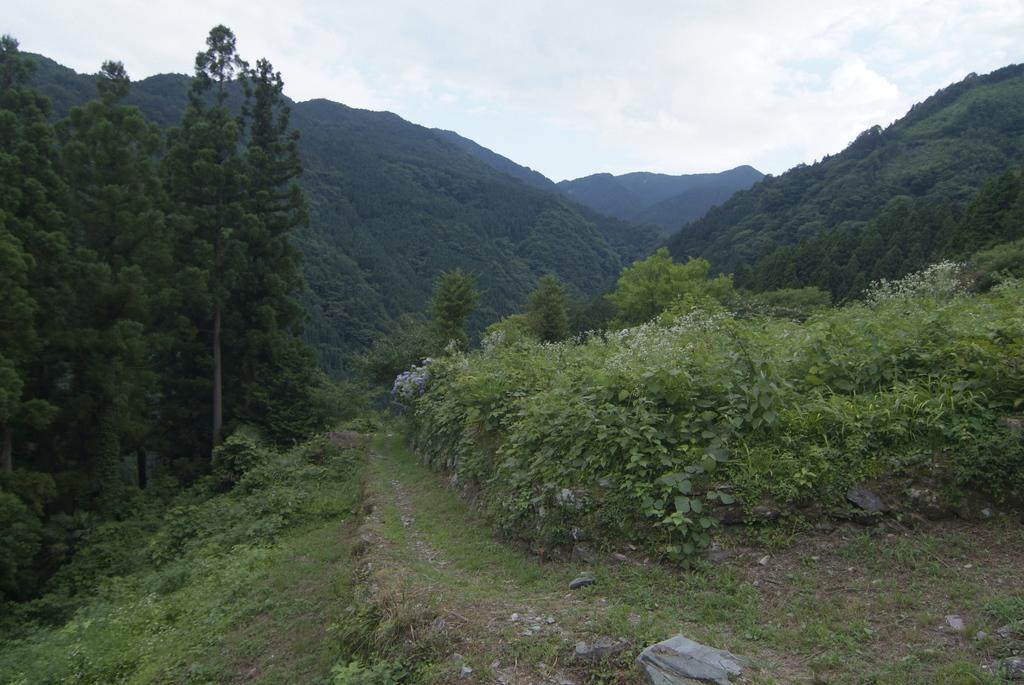Please provide a concise description of this image. This image looks like it is clicked in the forest. In this picture, there are many plants and trees along with the mountains. At the top, there are clouds in the sky. And there is a rock at the bottom. 